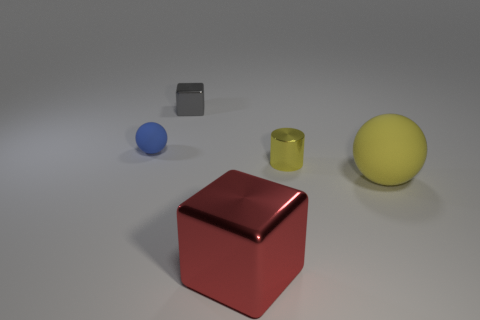Add 3 small cyan cylinders. How many objects exist? 8 Subtract all spheres. How many objects are left? 3 Add 4 small blue spheres. How many small blue spheres are left? 5 Add 1 red rubber things. How many red rubber things exist? 1 Subtract 0 cyan cylinders. How many objects are left? 5 Subtract all blue metallic objects. Subtract all red metallic objects. How many objects are left? 4 